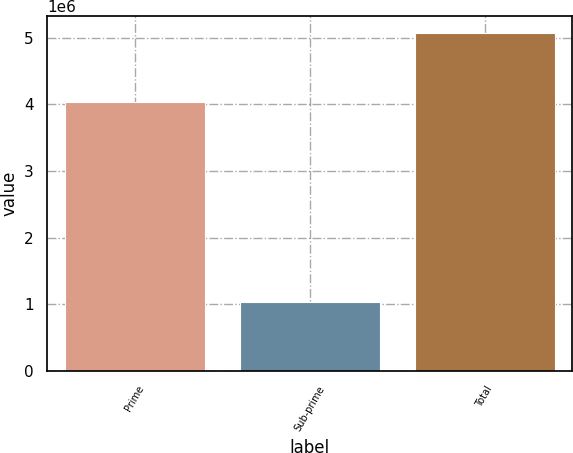<chart> <loc_0><loc_0><loc_500><loc_500><bar_chart><fcel>Prime<fcel>Sub-prime<fcel>Total<nl><fcel>4.03558e+06<fcel>1.03753e+06<fcel>5.07312e+06<nl></chart> 